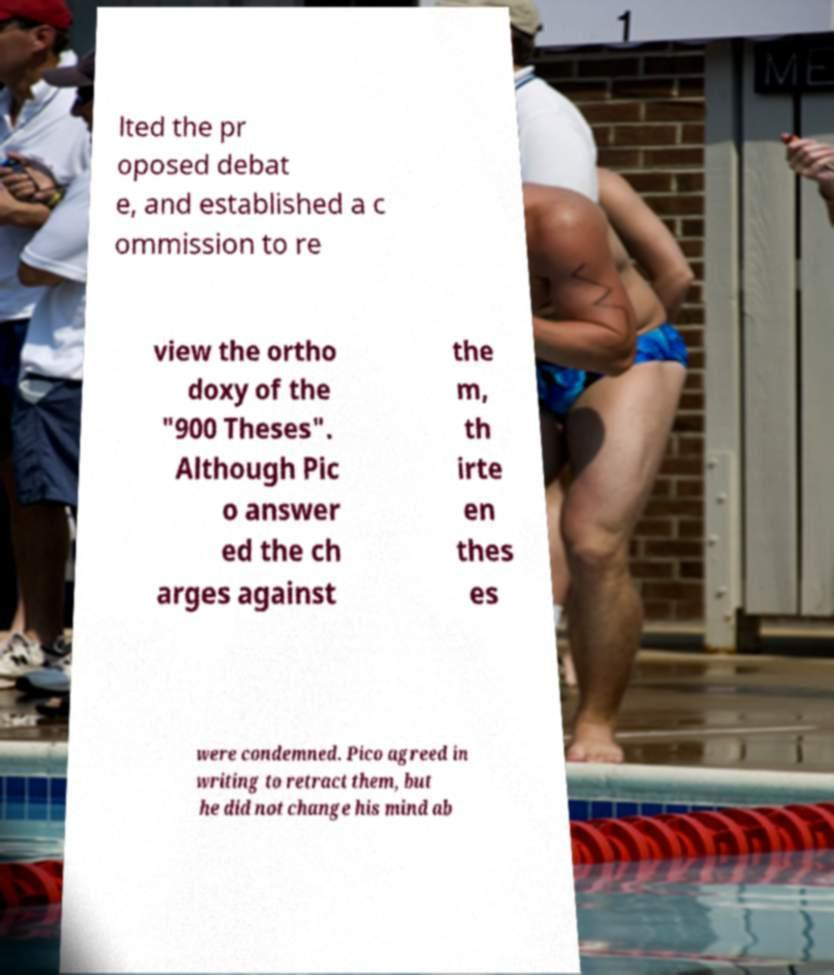Could you assist in decoding the text presented in this image and type it out clearly? lted the pr oposed debat e, and established a c ommission to re view the ortho doxy of the "900 Theses". Although Pic o answer ed the ch arges against the m, th irte en thes es were condemned. Pico agreed in writing to retract them, but he did not change his mind ab 